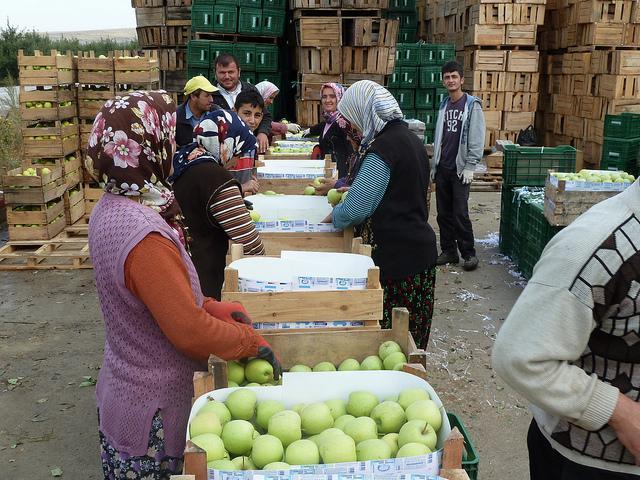How many people are there?
Give a very brief answer. 5. How many elephants are there?
Give a very brief answer. 0. 